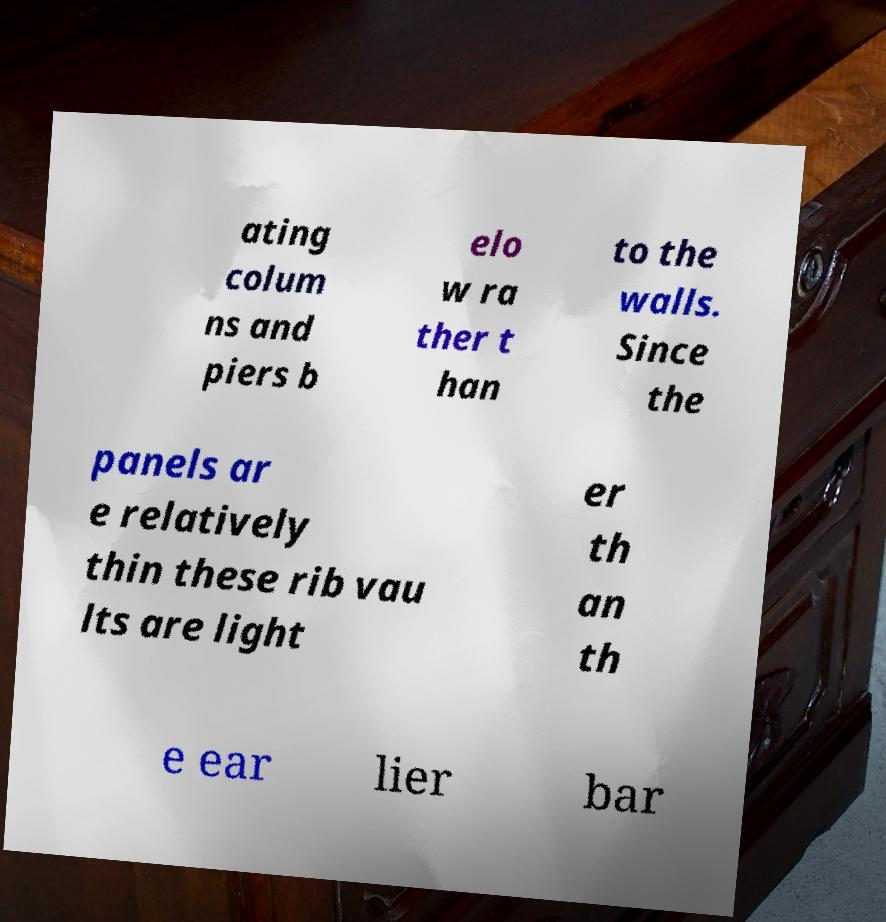Could you extract and type out the text from this image? ating colum ns and piers b elo w ra ther t han to the walls. Since the panels ar e relatively thin these rib vau lts are light er th an th e ear lier bar 